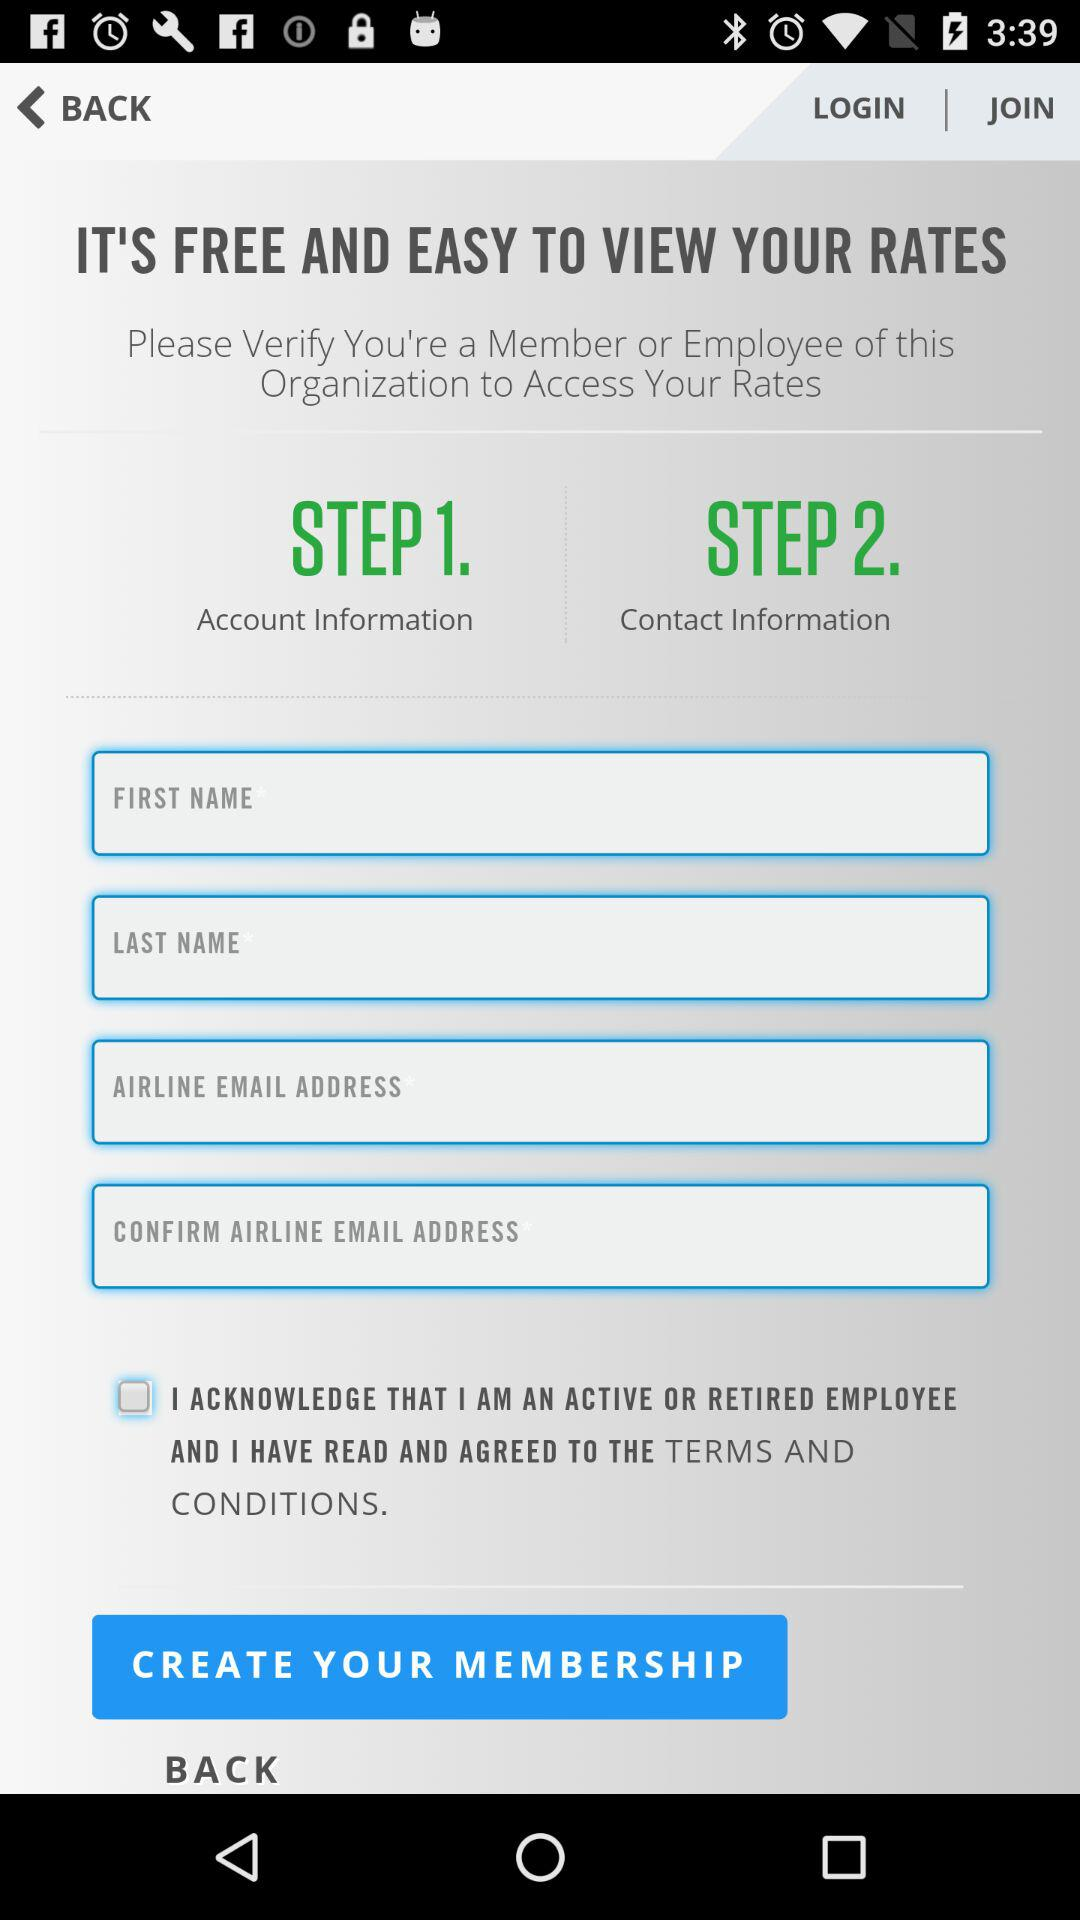At which step is contact information provided? Contact information is provided at the second step. 